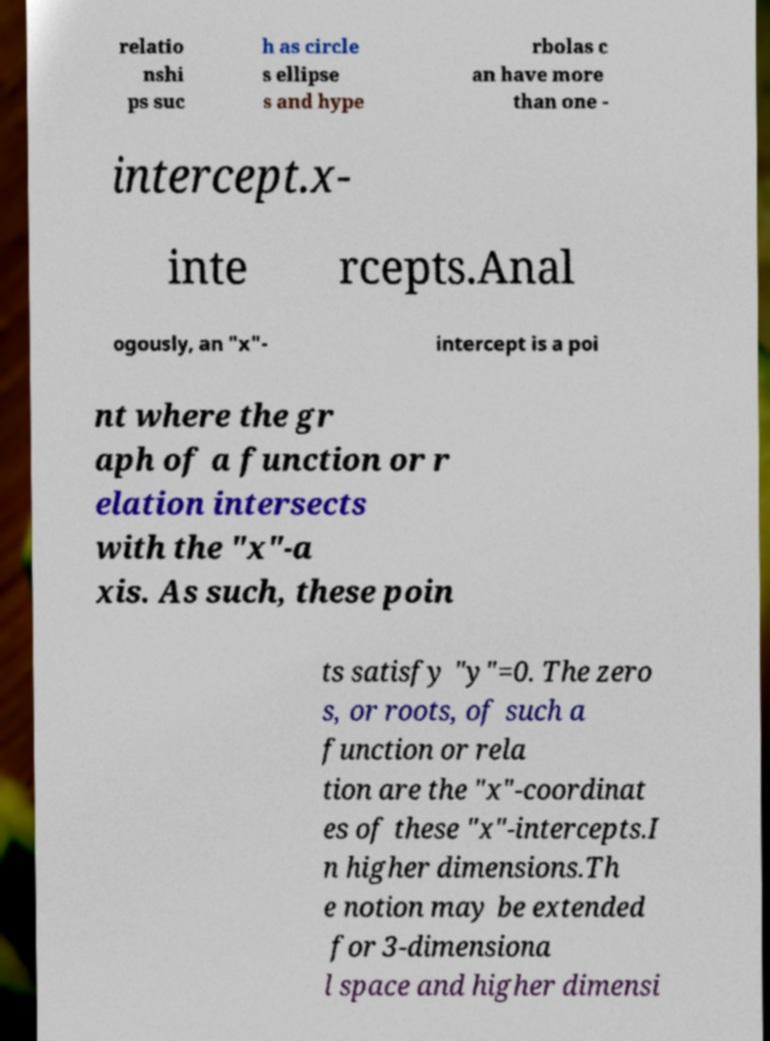Please read and relay the text visible in this image. What does it say? relatio nshi ps suc h as circle s ellipse s and hype rbolas c an have more than one - intercept.x- inte rcepts.Anal ogously, an "x"- intercept is a poi nt where the gr aph of a function or r elation intersects with the "x"-a xis. As such, these poin ts satisfy "y"=0. The zero s, or roots, of such a function or rela tion are the "x"-coordinat es of these "x"-intercepts.I n higher dimensions.Th e notion may be extended for 3-dimensiona l space and higher dimensi 